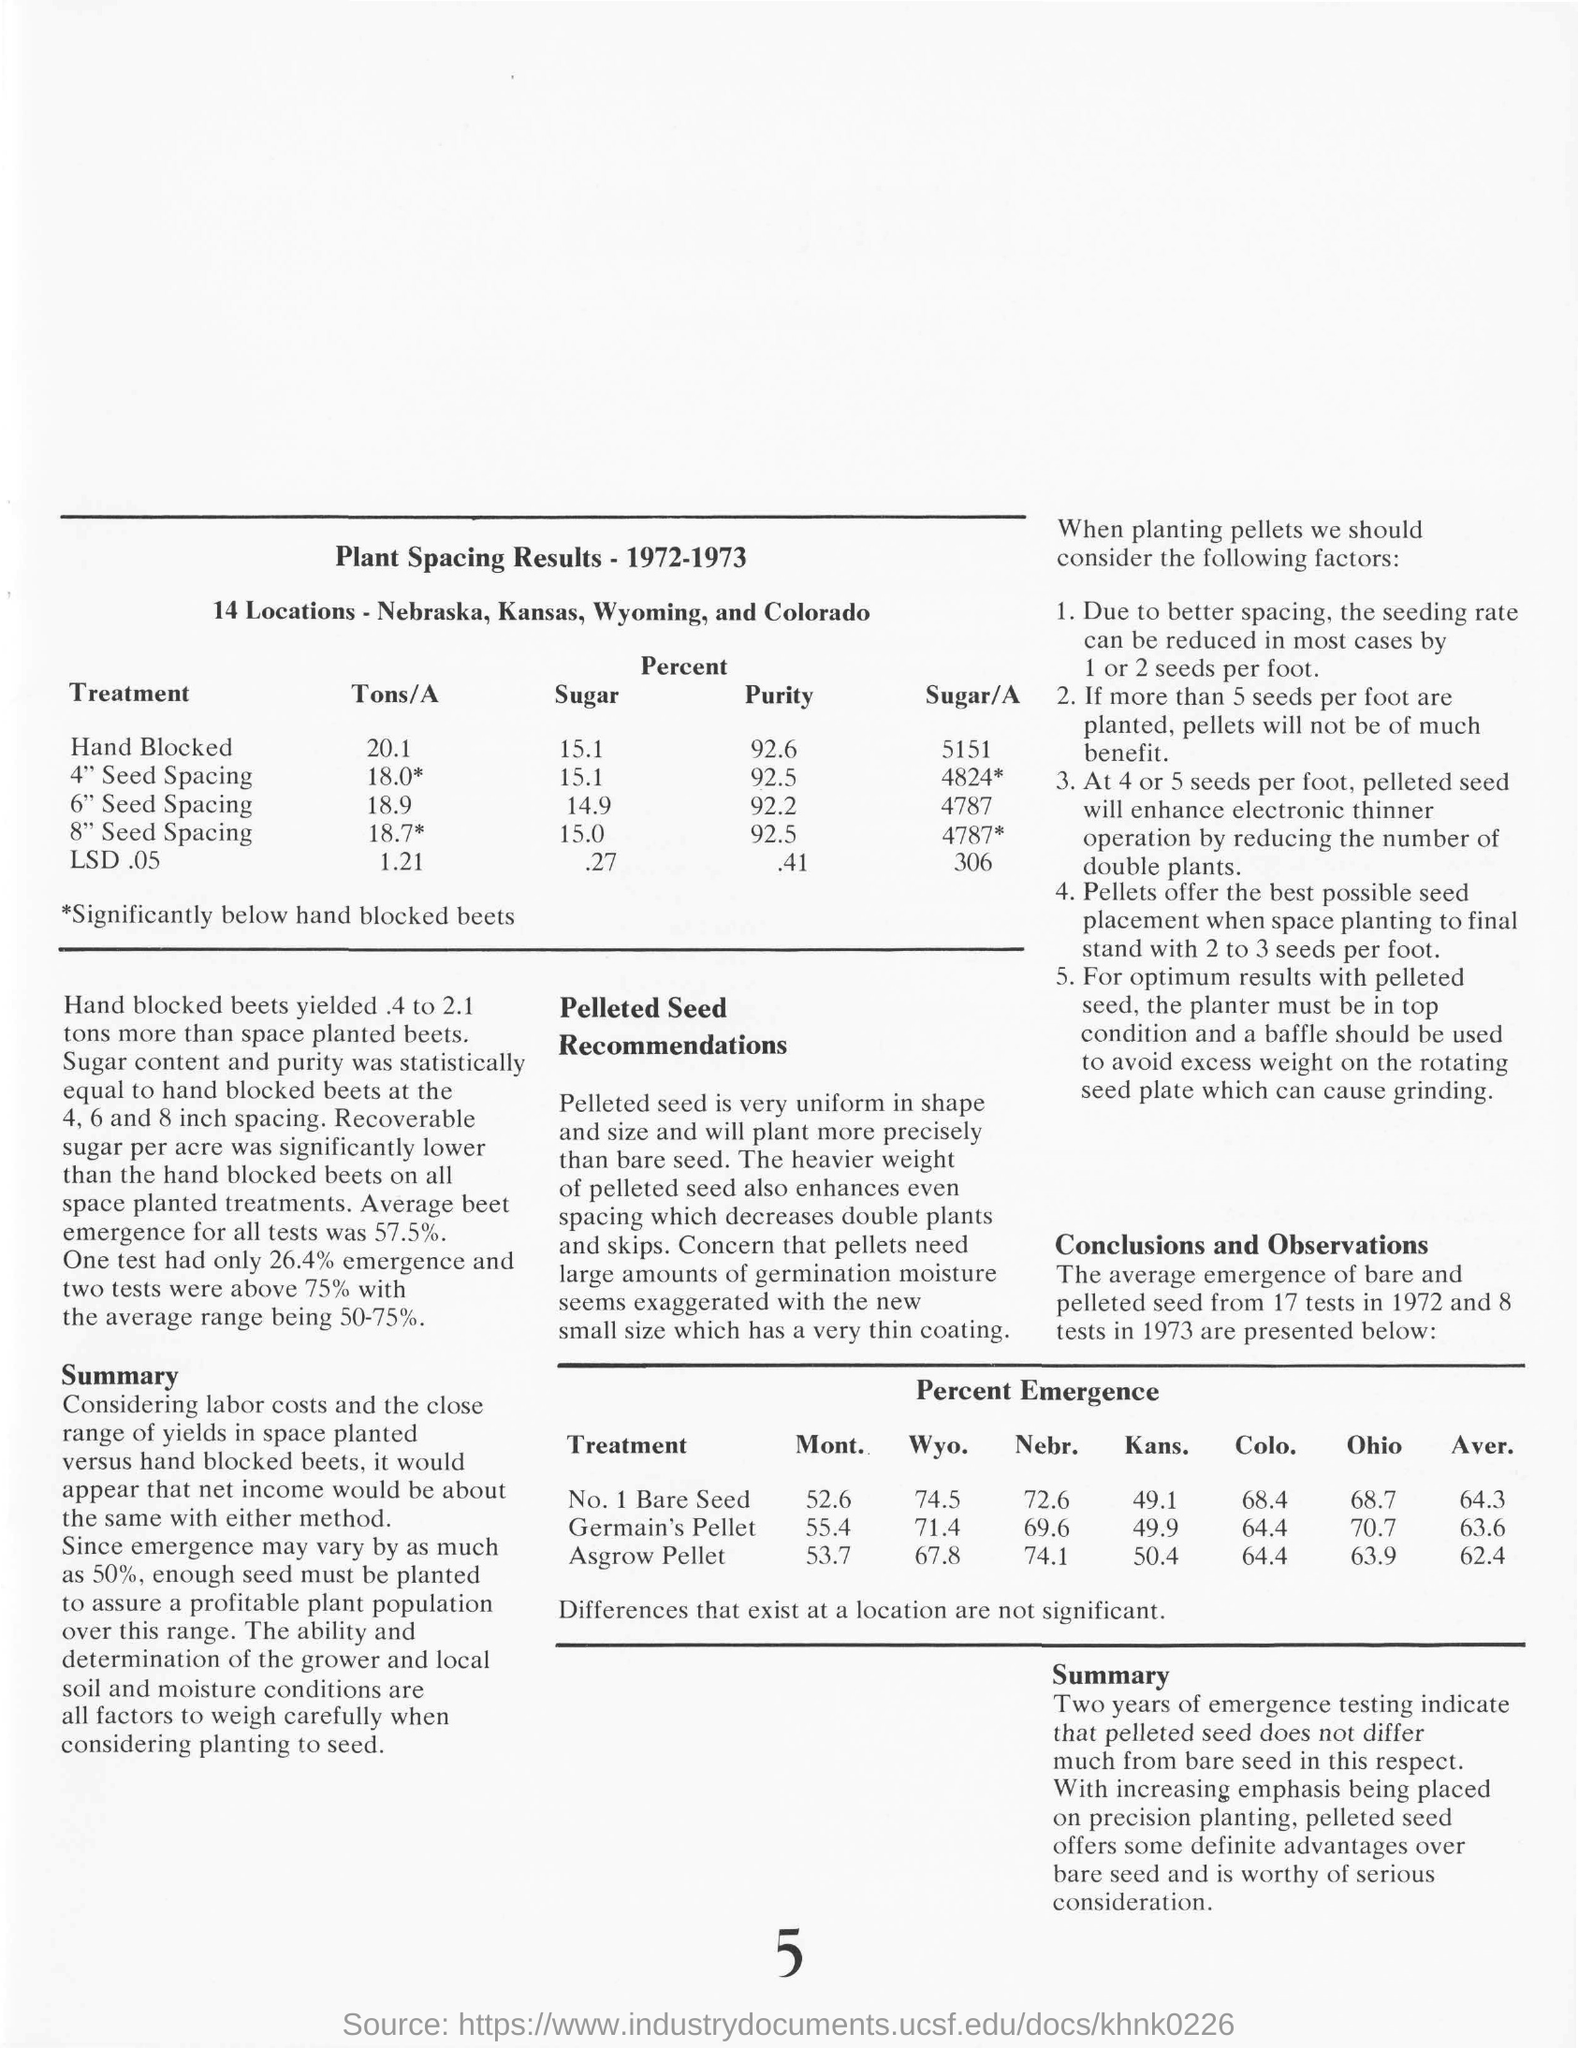Indicate a few pertinent items in this graphic. The page number is 5. 